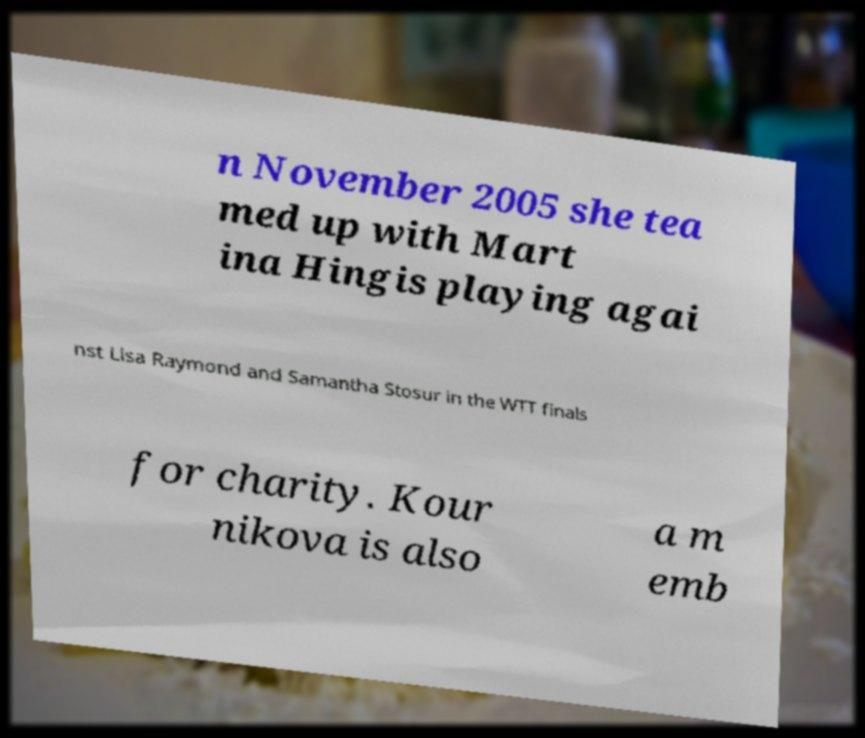Could you assist in decoding the text presented in this image and type it out clearly? n November 2005 she tea med up with Mart ina Hingis playing agai nst Lisa Raymond and Samantha Stosur in the WTT finals for charity. Kour nikova is also a m emb 